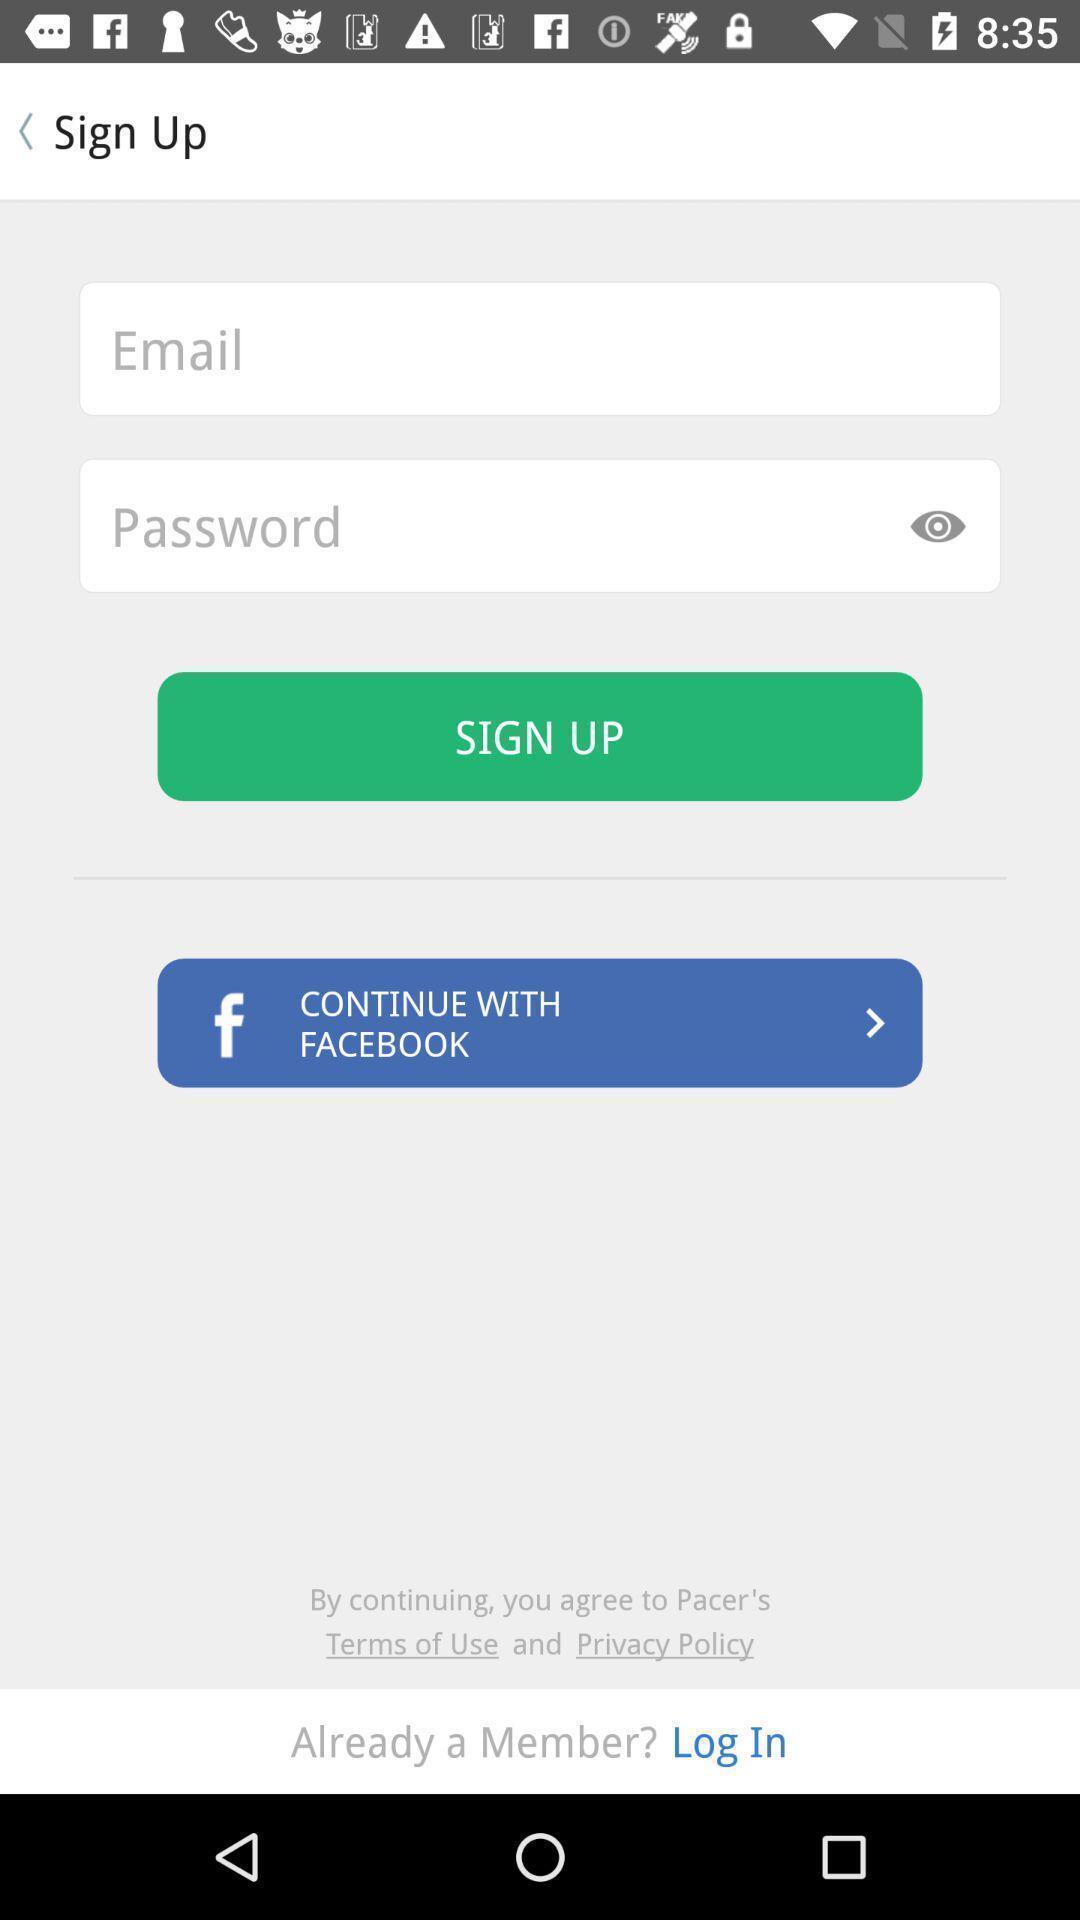Describe the key features of this screenshot. Sign up page. 